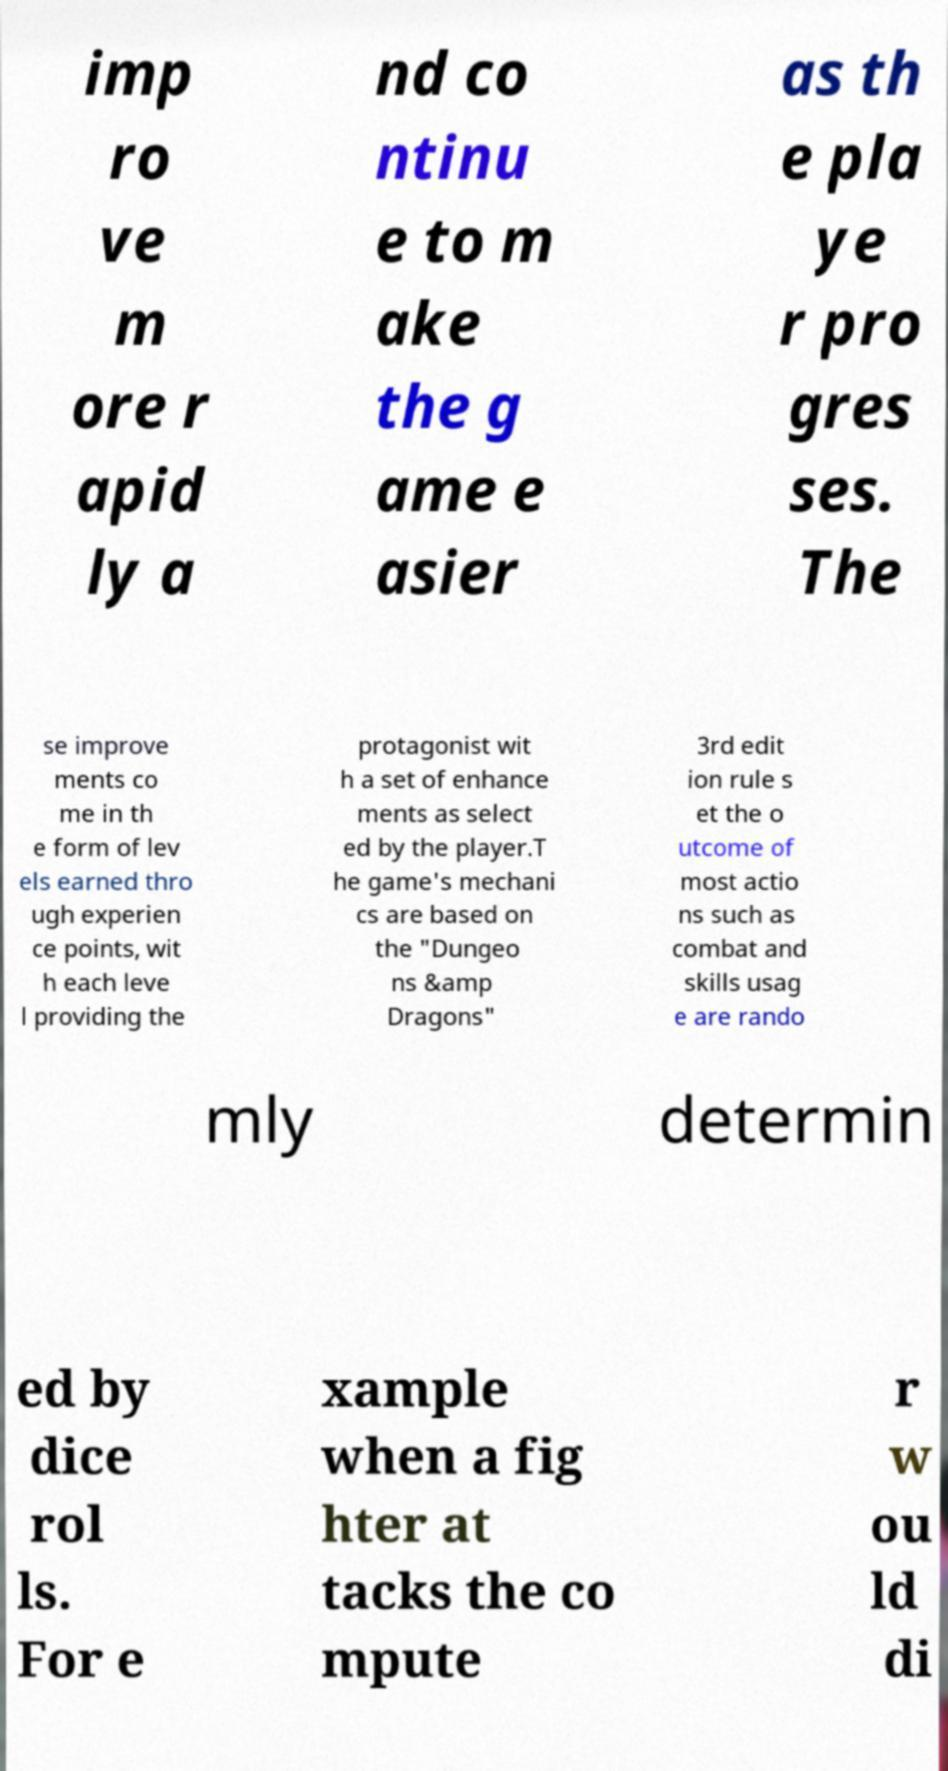Can you read and provide the text displayed in the image?This photo seems to have some interesting text. Can you extract and type it out for me? imp ro ve m ore r apid ly a nd co ntinu e to m ake the g ame e asier as th e pla ye r pro gres ses. The se improve ments co me in th e form of lev els earned thro ugh experien ce points, wit h each leve l providing the protagonist wit h a set of enhance ments as select ed by the player.T he game's mechani cs are based on the "Dungeo ns &amp Dragons" 3rd edit ion rule s et the o utcome of most actio ns such as combat and skills usag e are rando mly determin ed by dice rol ls. For e xample when a fig hter at tacks the co mpute r w ou ld di 